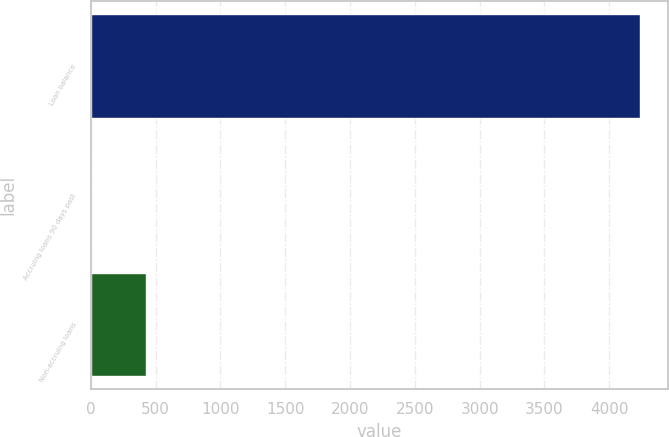Convert chart. <chart><loc_0><loc_0><loc_500><loc_500><bar_chart><fcel>Loan balance<fcel>Accruing loans 90 days past<fcel>Non-accruing loans<nl><fcel>4241<fcel>1<fcel>425<nl></chart> 